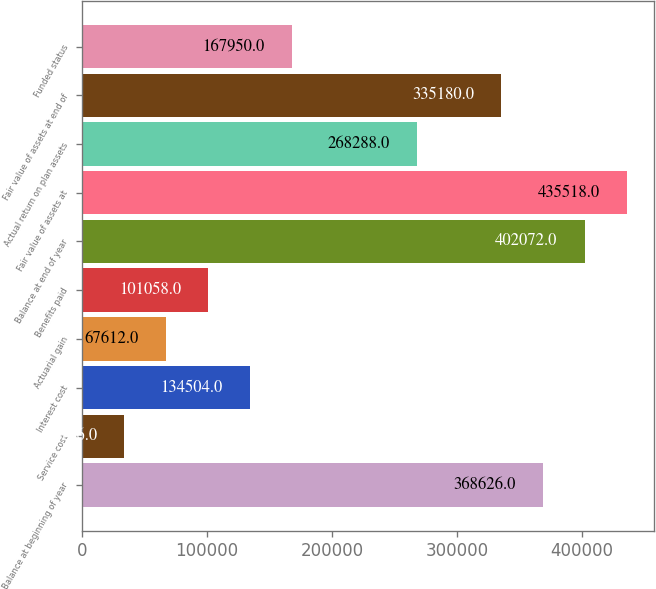Convert chart to OTSL. <chart><loc_0><loc_0><loc_500><loc_500><bar_chart><fcel>Balance at beginning of year<fcel>Service cost<fcel>Interest cost<fcel>Actuarial gain<fcel>Benefits paid<fcel>Balance at end of year<fcel>Fair value of assets at<fcel>Actual return on plan assets<fcel>Fair value of assets at end of<fcel>Funded status<nl><fcel>368626<fcel>34166<fcel>134504<fcel>67612<fcel>101058<fcel>402072<fcel>435518<fcel>268288<fcel>335180<fcel>167950<nl></chart> 